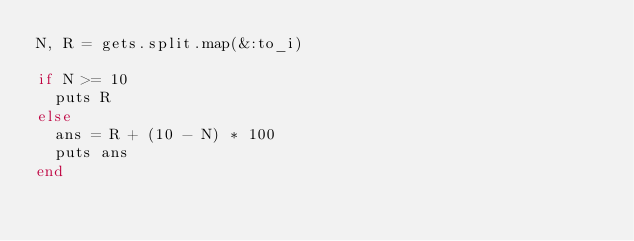Convert code to text. <code><loc_0><loc_0><loc_500><loc_500><_Ruby_>N, R = gets.split.map(&:to_i)

if N >= 10
  puts R
else
  ans = R + (10 - N) * 100
  puts ans
end</code> 